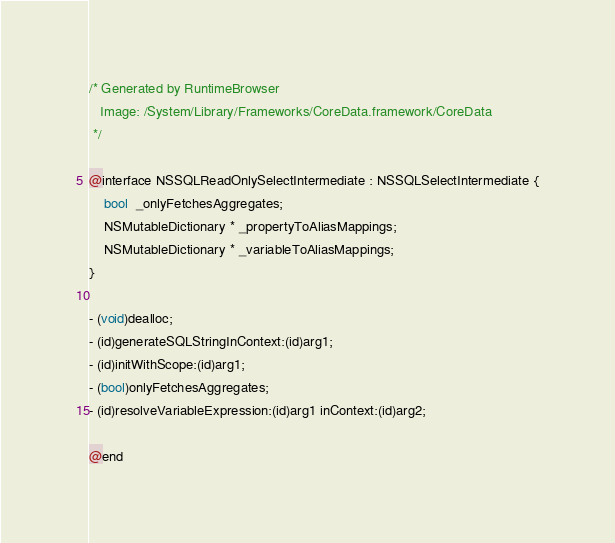<code> <loc_0><loc_0><loc_500><loc_500><_C_>/* Generated by RuntimeBrowser
   Image: /System/Library/Frameworks/CoreData.framework/CoreData
 */

@interface NSSQLReadOnlySelectIntermediate : NSSQLSelectIntermediate {
    bool  _onlyFetchesAggregates;
    NSMutableDictionary * _propertyToAliasMappings;
    NSMutableDictionary * _variableToAliasMappings;
}

- (void)dealloc;
- (id)generateSQLStringInContext:(id)arg1;
- (id)initWithScope:(id)arg1;
- (bool)onlyFetchesAggregates;
- (id)resolveVariableExpression:(id)arg1 inContext:(id)arg2;

@end
</code> 